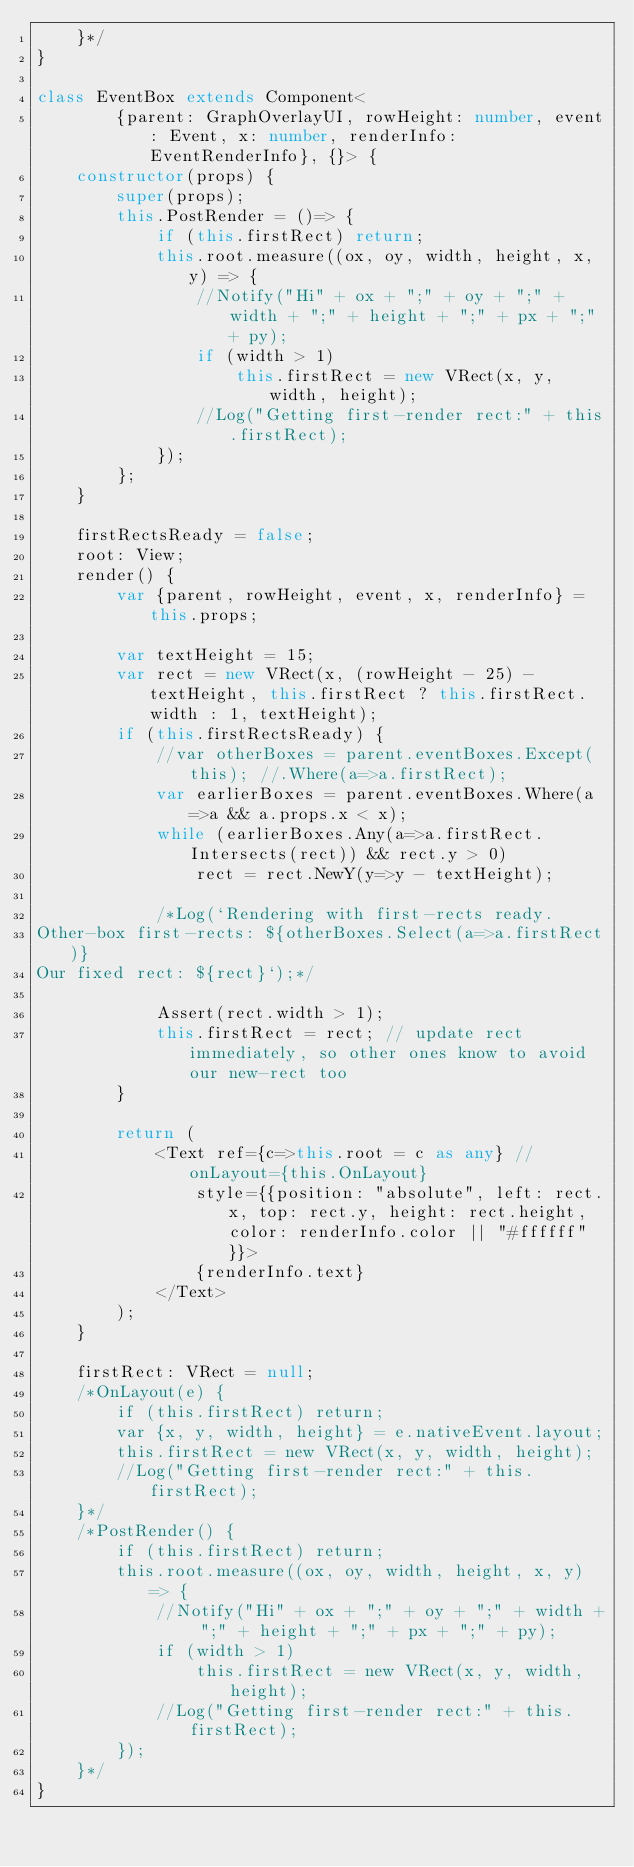Convert code to text. <code><loc_0><loc_0><loc_500><loc_500><_TypeScript_>	}*/
}

class EventBox extends Component<
		{parent: GraphOverlayUI, rowHeight: number, event: Event, x: number, renderInfo: EventRenderInfo}, {}> {
	constructor(props) {
		super(props);
		this.PostRender = ()=> {
			if (this.firstRect) return;
			this.root.measure((ox, oy, width, height, x, y) => {
				//Notify("Hi" + ox + ";" + oy + ";" + width + ";" + height + ";" + px + ";" + py);
				if (width > 1)
					this.firstRect = new VRect(x, y, width, height);
				//Log("Getting first-render rect:" + this.firstRect);
			});
		};
	}

	firstRectsReady = false;
	root: View;
	render() {
		var {parent, rowHeight, event, x, renderInfo} = this.props;

		var textHeight = 15;
		var rect = new VRect(x, (rowHeight - 25) - textHeight, this.firstRect ? this.firstRect.width : 1, textHeight);
		if (this.firstRectsReady) {
			//var otherBoxes = parent.eventBoxes.Except(this); //.Where(a=>a.firstRect);
			var earlierBoxes = parent.eventBoxes.Where(a=>a && a.props.x < x);
			while (earlierBoxes.Any(a=>a.firstRect.Intersects(rect)) && rect.y > 0)
				rect = rect.NewY(y=>y - textHeight);

			/*Log(`Rendering with first-rects ready.
Other-box first-rects: ${otherBoxes.Select(a=>a.firstRect)}
Our fixed rect: ${rect}`);*/

			Assert(rect.width > 1);
			this.firstRect = rect; // update rect immediately, so other ones know to avoid our new-rect too
		}

		return (
			<Text ref={c=>this.root = c as any} //onLayout={this.OnLayout}
				style={{position: "absolute", left: rect.x, top: rect.y, height: rect.height, color: renderInfo.color || "#ffffff"}}>
				{renderInfo.text}
			</Text>
		);
	}

	firstRect: VRect = null;
	/*OnLayout(e) {
		if (this.firstRect) return;
		var {x, y, width, height} = e.nativeEvent.layout;
		this.firstRect = new VRect(x, y, width, height);
		//Log("Getting first-render rect:" + this.firstRect);
	}*/
	/*PostRender() {
		if (this.firstRect) return;
		this.root.measure((ox, oy, width, height, x, y) => {
			//Notify("Hi" + ox + ";" + oy + ";" + width + ";" + height + ";" + px + ";" + py);
			if (width > 1)
				this.firstRect = new VRect(x, y, width, height);
			//Log("Getting first-render rect:" + this.firstRect);
		});
	}*/
}</code> 